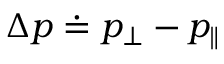Convert formula to latex. <formula><loc_0><loc_0><loc_500><loc_500>\Delta p \doteq p _ { \perp } - p _ { \| }</formula> 